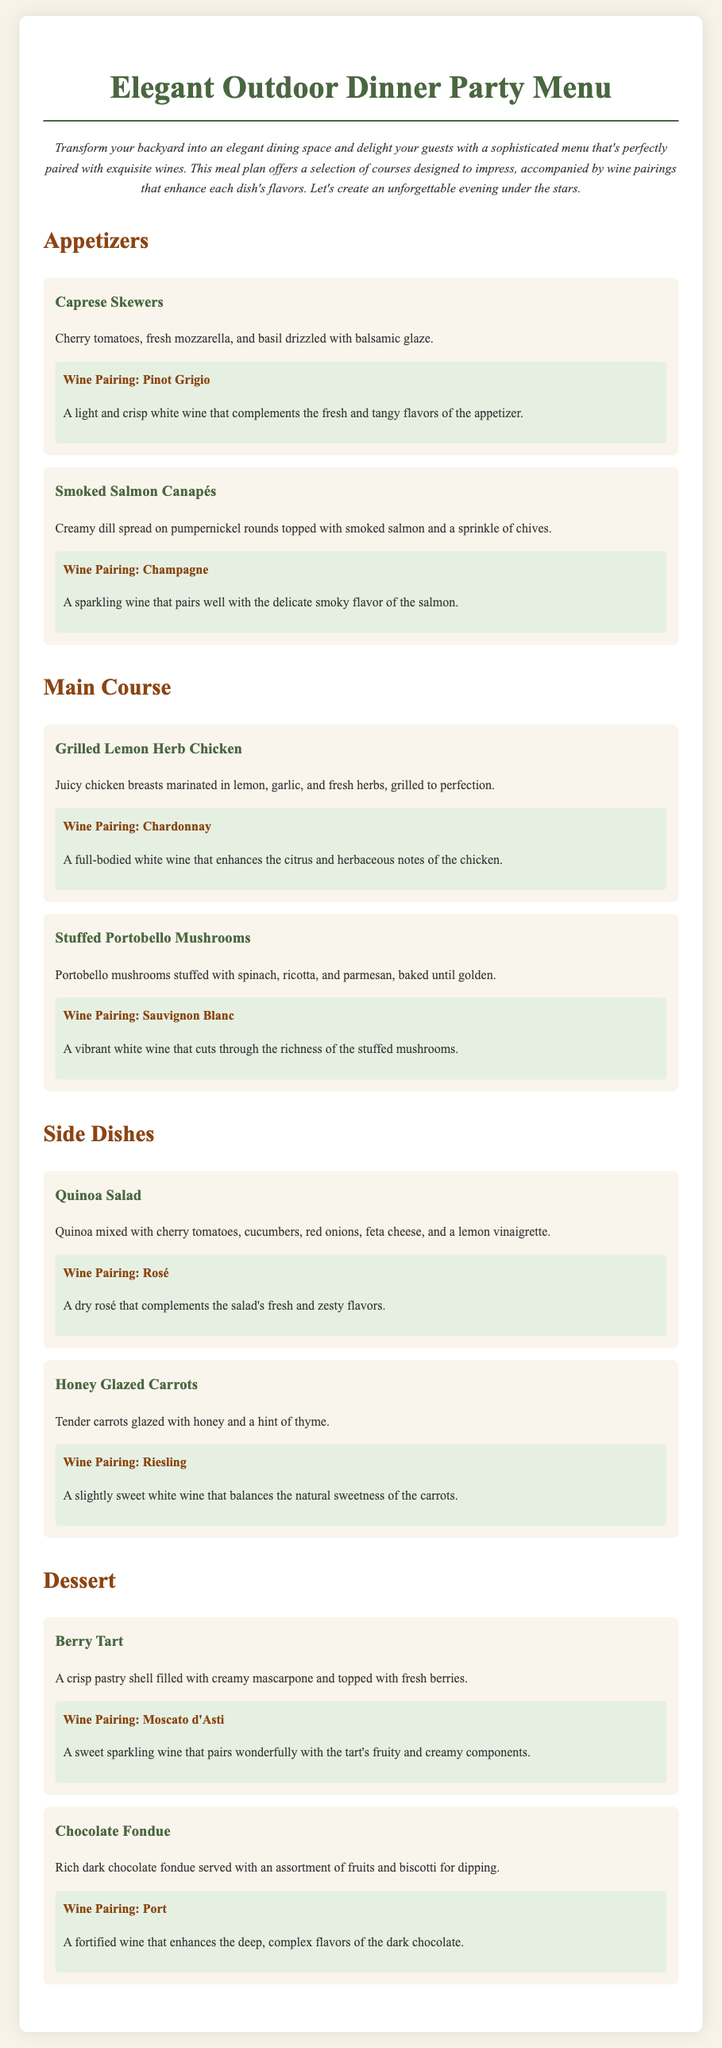What is the main theme of the dinner party menu? The main theme focuses on creating an elegant outdoor dining experience with a sophisticated selection of dishes and wine pairings.
Answer: Elegant outdoor dinner party How many appetizers are included in the menu? There are two appetizers listed in the menu section.
Answer: 2 What wine is paired with the Grilled Lemon Herb Chicken? The wine pairing listed enhances the flavors of the main course dish.
Answer: Chardonnay What type of dessert features fresh berries? This dessert includes a specific pastry that complements the tartness of the berries.
Answer: Berry Tart Which wine is suggested with the Honey Glazed Carrots? The pairing complements the specific sweet flavors of the side dish.
Answer: Riesling What is the base ingredient of the Smoked Salmon Canapés? This particular dish features a specific type of bread as its base.
Answer: Pumpernickel Which dish is suitable for vegetarians? This dish is entirely plant-based and meets vegetarian criteria.
Answer: Stuffed Portobello Mushrooms What is the garnish for the Caprese Skewers? This ingredient adds flavor and freshness to the appetizer offering.
Answer: Basil Which dessert is chocolate-based? This dessert includes a rich component that defines its flavor profile.
Answer: Chocolate Fondue 